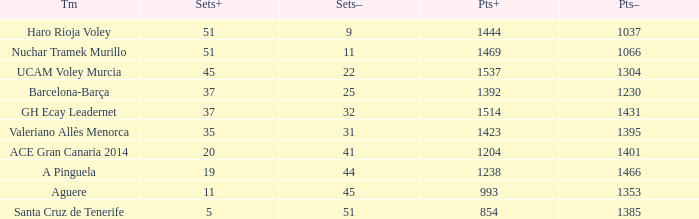What is the highest Sets+ number for Valeriano Allès Menorca when the Sets- number was larger than 31? None. 